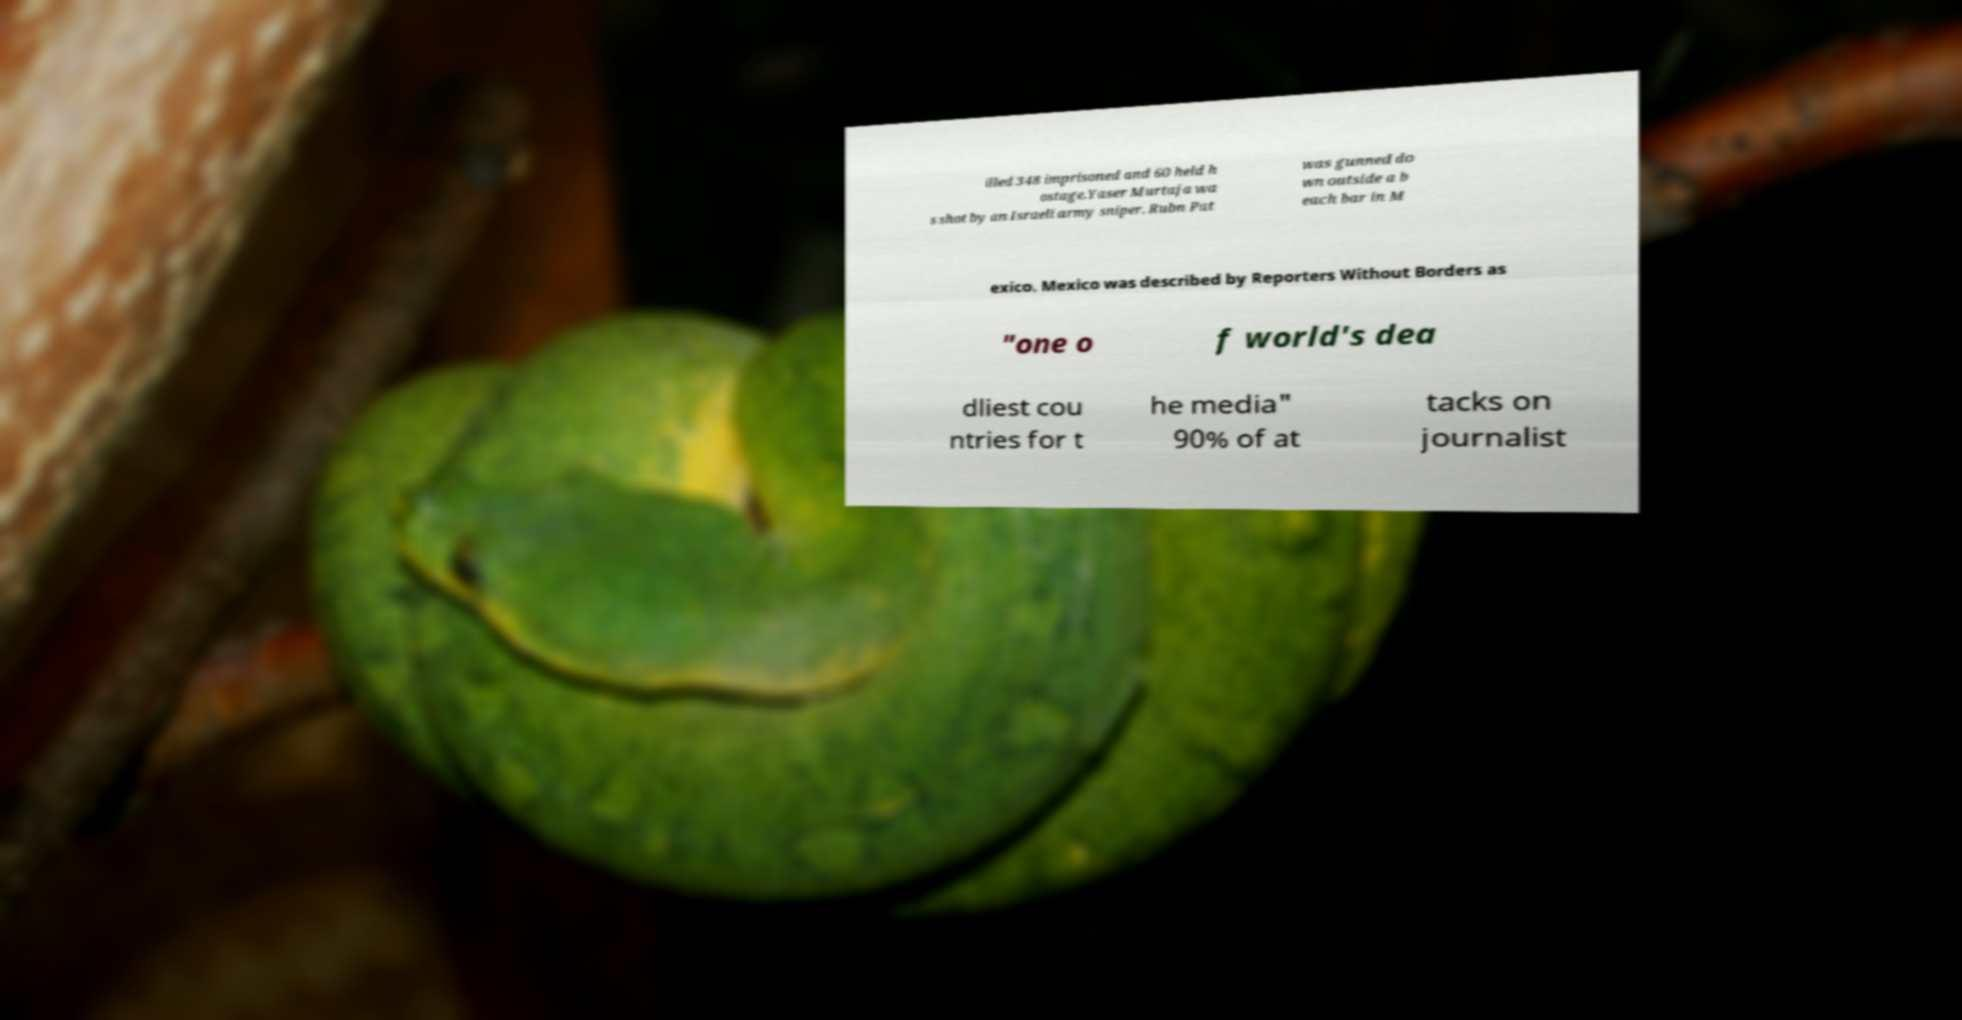Please read and relay the text visible in this image. What does it say? illed 348 imprisoned and 60 held h ostage.Yaser Murtaja wa s shot by an Israeli army sniper. Rubn Pat was gunned do wn outside a b each bar in M exico. Mexico was described by Reporters Without Borders as "one o f world's dea dliest cou ntries for t he media" 90% of at tacks on journalist 